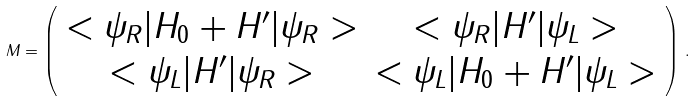Convert formula to latex. <formula><loc_0><loc_0><loc_500><loc_500>M = \left ( \begin{array} { c c } < \psi _ { R } | H _ { 0 } + H ^ { \prime } | \psi _ { R } > & < \psi _ { R } | H ^ { \prime } | \psi _ { L } > \\ < \psi _ { L } | H ^ { \prime } | \psi _ { R } > & < \psi _ { L } | H _ { 0 } + H ^ { \prime } | \psi _ { L } > \end{array} \right ) \, { . }</formula> 